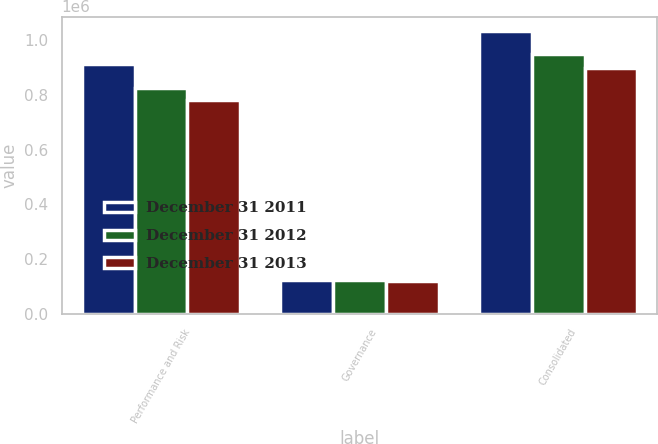Convert chart. <chart><loc_0><loc_0><loc_500><loc_500><stacked_bar_chart><ecel><fcel>Performance and Risk<fcel>Governance<fcel>Consolidated<nl><fcel>December 31 2011<fcel>913364<fcel>122303<fcel>1.03567e+06<nl><fcel>December 31 2012<fcel>826990<fcel>123151<fcel>950141<nl><fcel>December 31 2013<fcel>781355<fcel>119586<fcel>900941<nl></chart> 